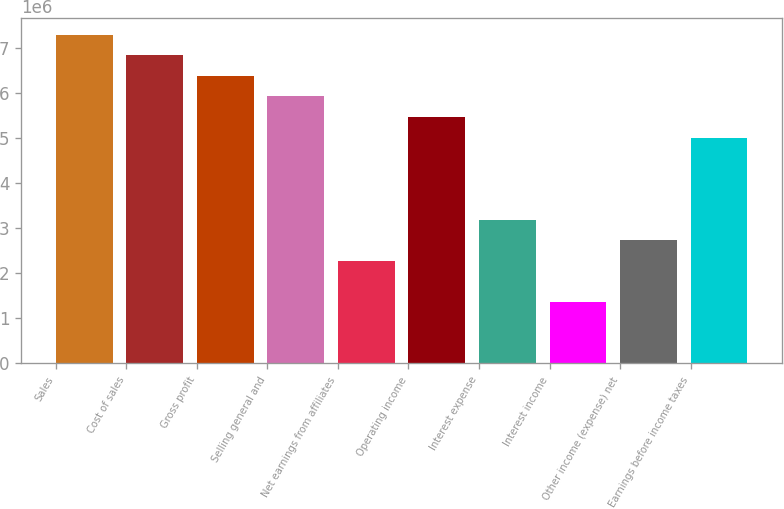Convert chart to OTSL. <chart><loc_0><loc_0><loc_500><loc_500><bar_chart><fcel>Sales<fcel>Cost of sales<fcel>Gross profit<fcel>Selling general and<fcel>Net earnings from affiliates<fcel>Operating income<fcel>Interest expense<fcel>Interest income<fcel>Other income (expense) net<fcel>Earnings before income taxes<nl><fcel>7.29765e+06<fcel>6.84154e+06<fcel>6.38544e+06<fcel>5.92934e+06<fcel>2.28052e+06<fcel>5.47324e+06<fcel>3.19272e+06<fcel>1.36831e+06<fcel>2.73662e+06<fcel>5.01713e+06<nl></chart> 